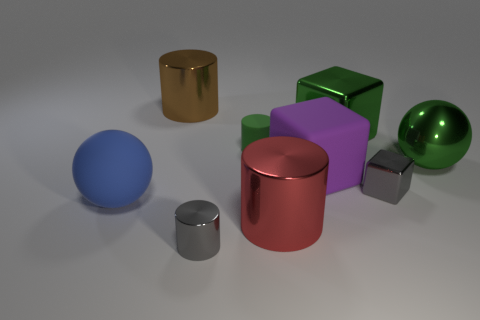How many large things are left of the small gray block and right of the large blue thing?
Your answer should be very brief. 4. The small metal block has what color?
Your answer should be very brief. Gray. Is there a blue thing that has the same material as the green cylinder?
Your response must be concise. Yes. Are there any metal cylinders behind the sphere that is on the right side of the green shiny thing behind the small green rubber thing?
Provide a succinct answer. Yes. There is a big matte block; are there any cylinders behind it?
Your response must be concise. Yes. Are there any shiny objects of the same color as the tiny cube?
Provide a short and direct response. Yes. What number of small things are blue balls or rubber blocks?
Make the answer very short. 0. Do the big cylinder that is on the right side of the small gray cylinder and the brown cylinder have the same material?
Offer a very short reply. Yes. What is the shape of the large metallic object that is on the left side of the tiny cylinder in front of the large green metal sphere that is behind the blue sphere?
Your answer should be very brief. Cylinder. How many brown objects are either big cubes or metallic blocks?
Ensure brevity in your answer.  0. 